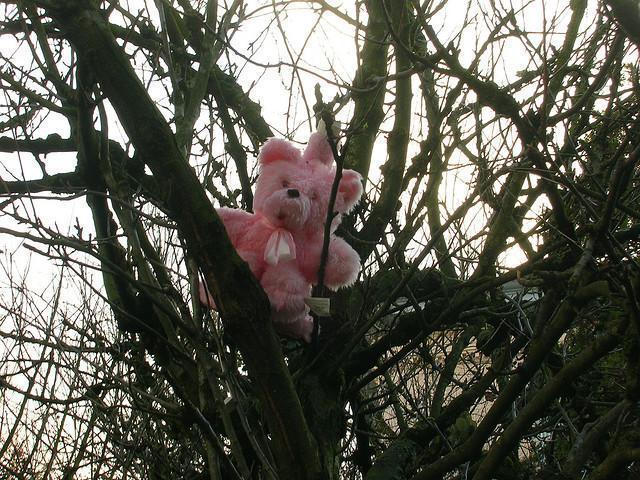How many people are in the room?
Give a very brief answer. 0. 